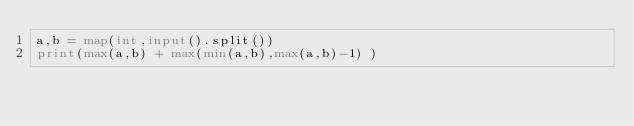<code> <loc_0><loc_0><loc_500><loc_500><_Python_>a,b = map(int,input().split())
print(max(a,b) + max(min(a,b),max(a,b)-1) )</code> 